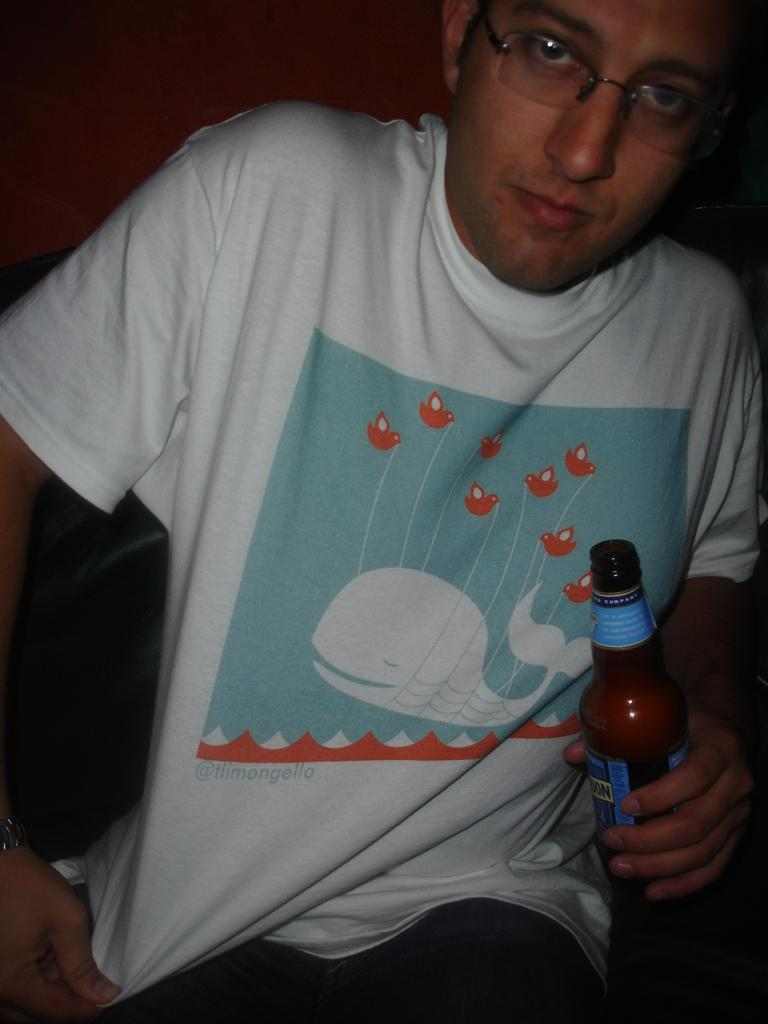What is the main subject of the image? There is a man in the image. What is the man doing in the image? The man is seated in the image. What is the man holding in his hand? The man is holding a beer bottle in his hand. What type of profit can be seen in the image? There is no profit visible in the image; it features a man seated and holding a beer bottle. What type of vessel is the man using to rub his hands in the image? There is no vessel or rubbing action depicted in the image. 